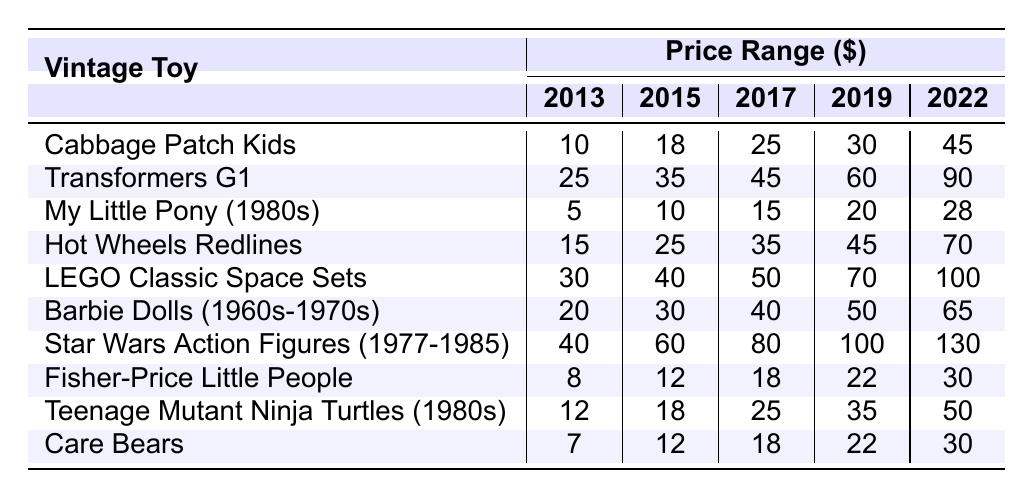What was the price of Cabbage Patch Kids in 2019? In the 2019 column, the price for Cabbage Patch Kids is listed as 30.
Answer: 30 What was the highest price for Star Wars Action Figures in 2022? The price of Star Wars Action Figures in 2022 is listed as 130, which is the highest price in that year.
Answer: 130 Was the price of My Little Pony (1980s) consistently under 20 from 2013 to 2019? Looking at the prices from 2013 to 2019, they are 5, 10, 15, 20 which shows that in 2019 it reached exactly 20, so it was not consistently under 20.
Answer: No What is the median price of Hot Wheels Redlines? The prices for Hot Wheels Redlines are 15, 25, 35, 45, and 70. Arranging these values, the median is the middle number which is 35.
Answer: 35 How much more expensive is LEGO Classic Space Sets in 2022 compared to the price in 2013? In 2022, the price of LEGO Classic Space Sets is 100, and in 2013 it was 30. The difference is 100 - 30 = 70.
Answer: 70 Which toy had the smallest price in 2015? The prices for each toy in 2015 can be compared: 18, 35, 10, 25, 40, 30, 60, 12, 18, 12. The smallest price is 10 for My Little Pony (1980s).
Answer: My Little Pony (1980s) What is the total price for Teenage Mutant Ninja Turtles from 2013 to 2022? The prices from 2013 to 2022 are 12, 18, 25, 35, and 50. Adding them up gives: 12 + 18 + 25 + 35 + 50 = 140.
Answer: 140 Was the price of Care Bears in 2016 higher than that of Fisher-Price Little People in the same year? The price of Care Bears in 2016 is 15 and Fisher-Price Little People is 15 as well. Since they are equal, Care Bears isn't higher.
Answer: No What is the price increase of Barbie Dolls (1960s-1970s) from 2013 to 2022? The price in 2013 is 20 and in 2022 it is 65. The increase is calculated by 65 - 20 = 45.
Answer: 45 Which vintage toy had the most significant price increase from 2013 to 2022? Comparing the price changes from 2013 to 2022 for all toys, Star Wars Action Figures increased from 40 to 130, which is a change of 90, the highest.
Answer: Star Wars Action Figures 